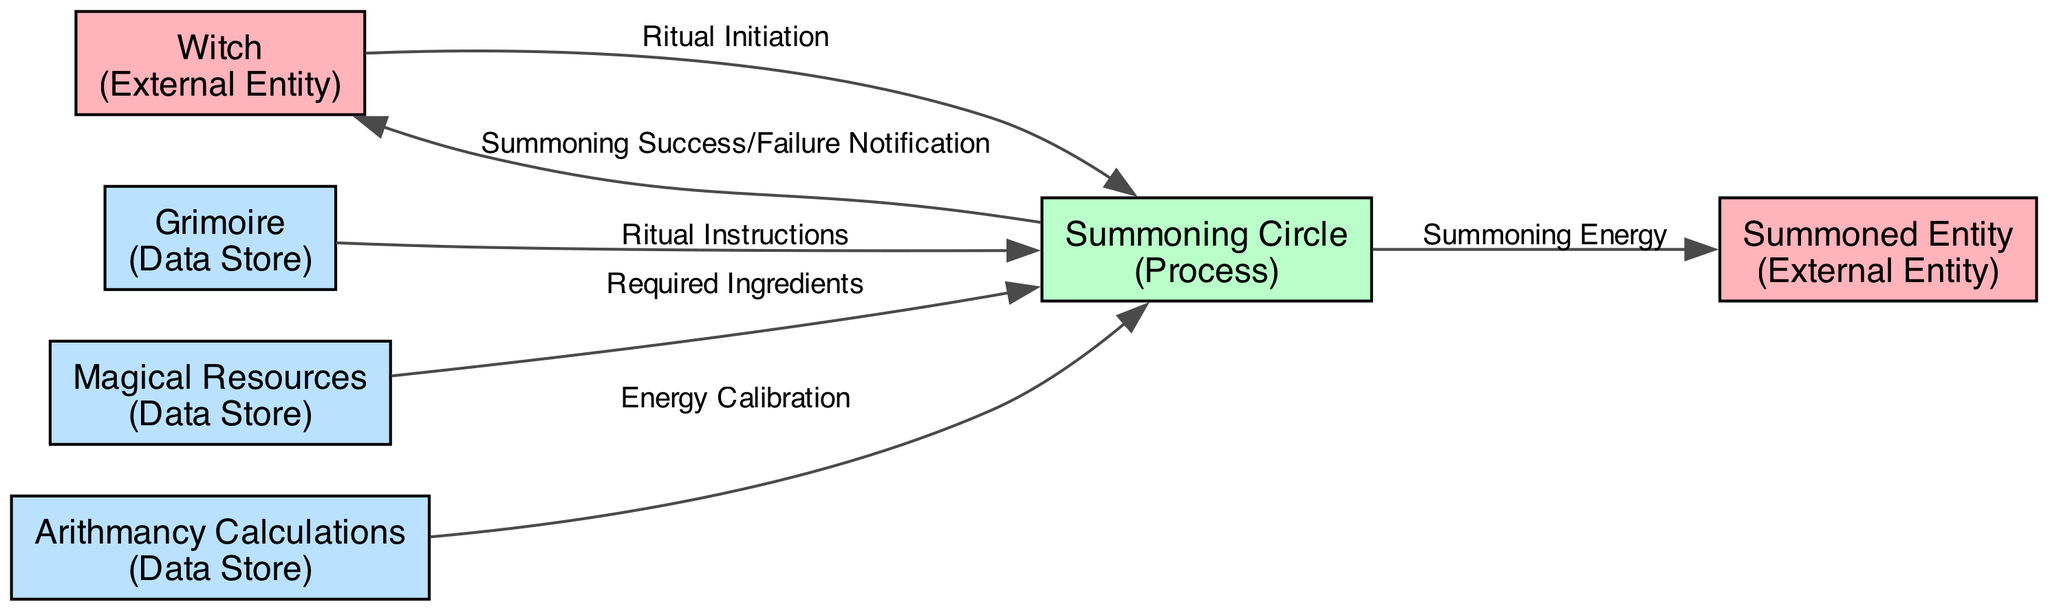What is the total number of external entities in the diagram? The diagram shows two external entities: "Witch" and "Summoned Entity." Both of these are identified as external entities, and no other entities of this type are present in the diagram.
Answer: 2 What does the Witch initiate in the ritual workflow? The Witch initiates the "Ritual Initiation," which is the starting action in the workflow that triggers the subsequent processes. This is indicated by the directed flow from the Witch to the Summoning Circle.
Answer: Ritual Initiation Which data store provides the instructions for the summoning ritual? The data flow from the "Grimoire" to the "Summoning Circle" signifies that the Grimoire is the source of the "Ritual Instructions," thus providing the necessary instructions for performing the summoning ritual.
Answer: Grimoire What type of data flow is produced from the Summoning Circle to the Witch? The data flow from the "Summoning Circle" to the "Witch" is labeled as "Summoning Success/Failure Notification." This indicates that after the ritual is completed, the Witch receives feedback regarding whether the summoning was successful or not.
Answer: Summoning Success/Failure Notification What is the source of the energy calibration for the summoning process? The energy calibration is provided by "Arithmancy Calculations," which flow into the "Summoning Circle." This indicates that the arithmancy calculations are essential for ensuring that the magical energies are properly aligned for the summoning to be effective.
Answer: Arithmancy Calculations How many data stores are involved in the summoning ritual workflow? The diagram displays three data stores: "Grimoire," "Magical Resources," and "Arithmancy Calculations." Each of these serves a unique purpose in the workflow, providing necessary information or materials for the summoning.
Answer: 3 What entity receives the summoning energy at the end of the process? The "Summoned Entity" is the one that receives the "Summoning Energy" generated from the "Summoning Circle." This indicates that the energy created in the circle is directed towards bringing forth the entity.
Answer: Summoned Entity Which data flow indicates the provision of magical ingredients? The flow labeled "Required Ingredients" indicates that the "Magical Resources" data store supplies ingredients needed for the ritual to the "Summoning Circle," essential for the summoning process.
Answer: Required Ingredients What is the function of the Summoning Circle in the workflow? The "Summoning Circle" acts as the central process where various inputs are provided, and the actual summoning takes place, making it crucial for the entire workflow. It integrates inputs from various sources and produces outcomes.
Answer: Central Process 